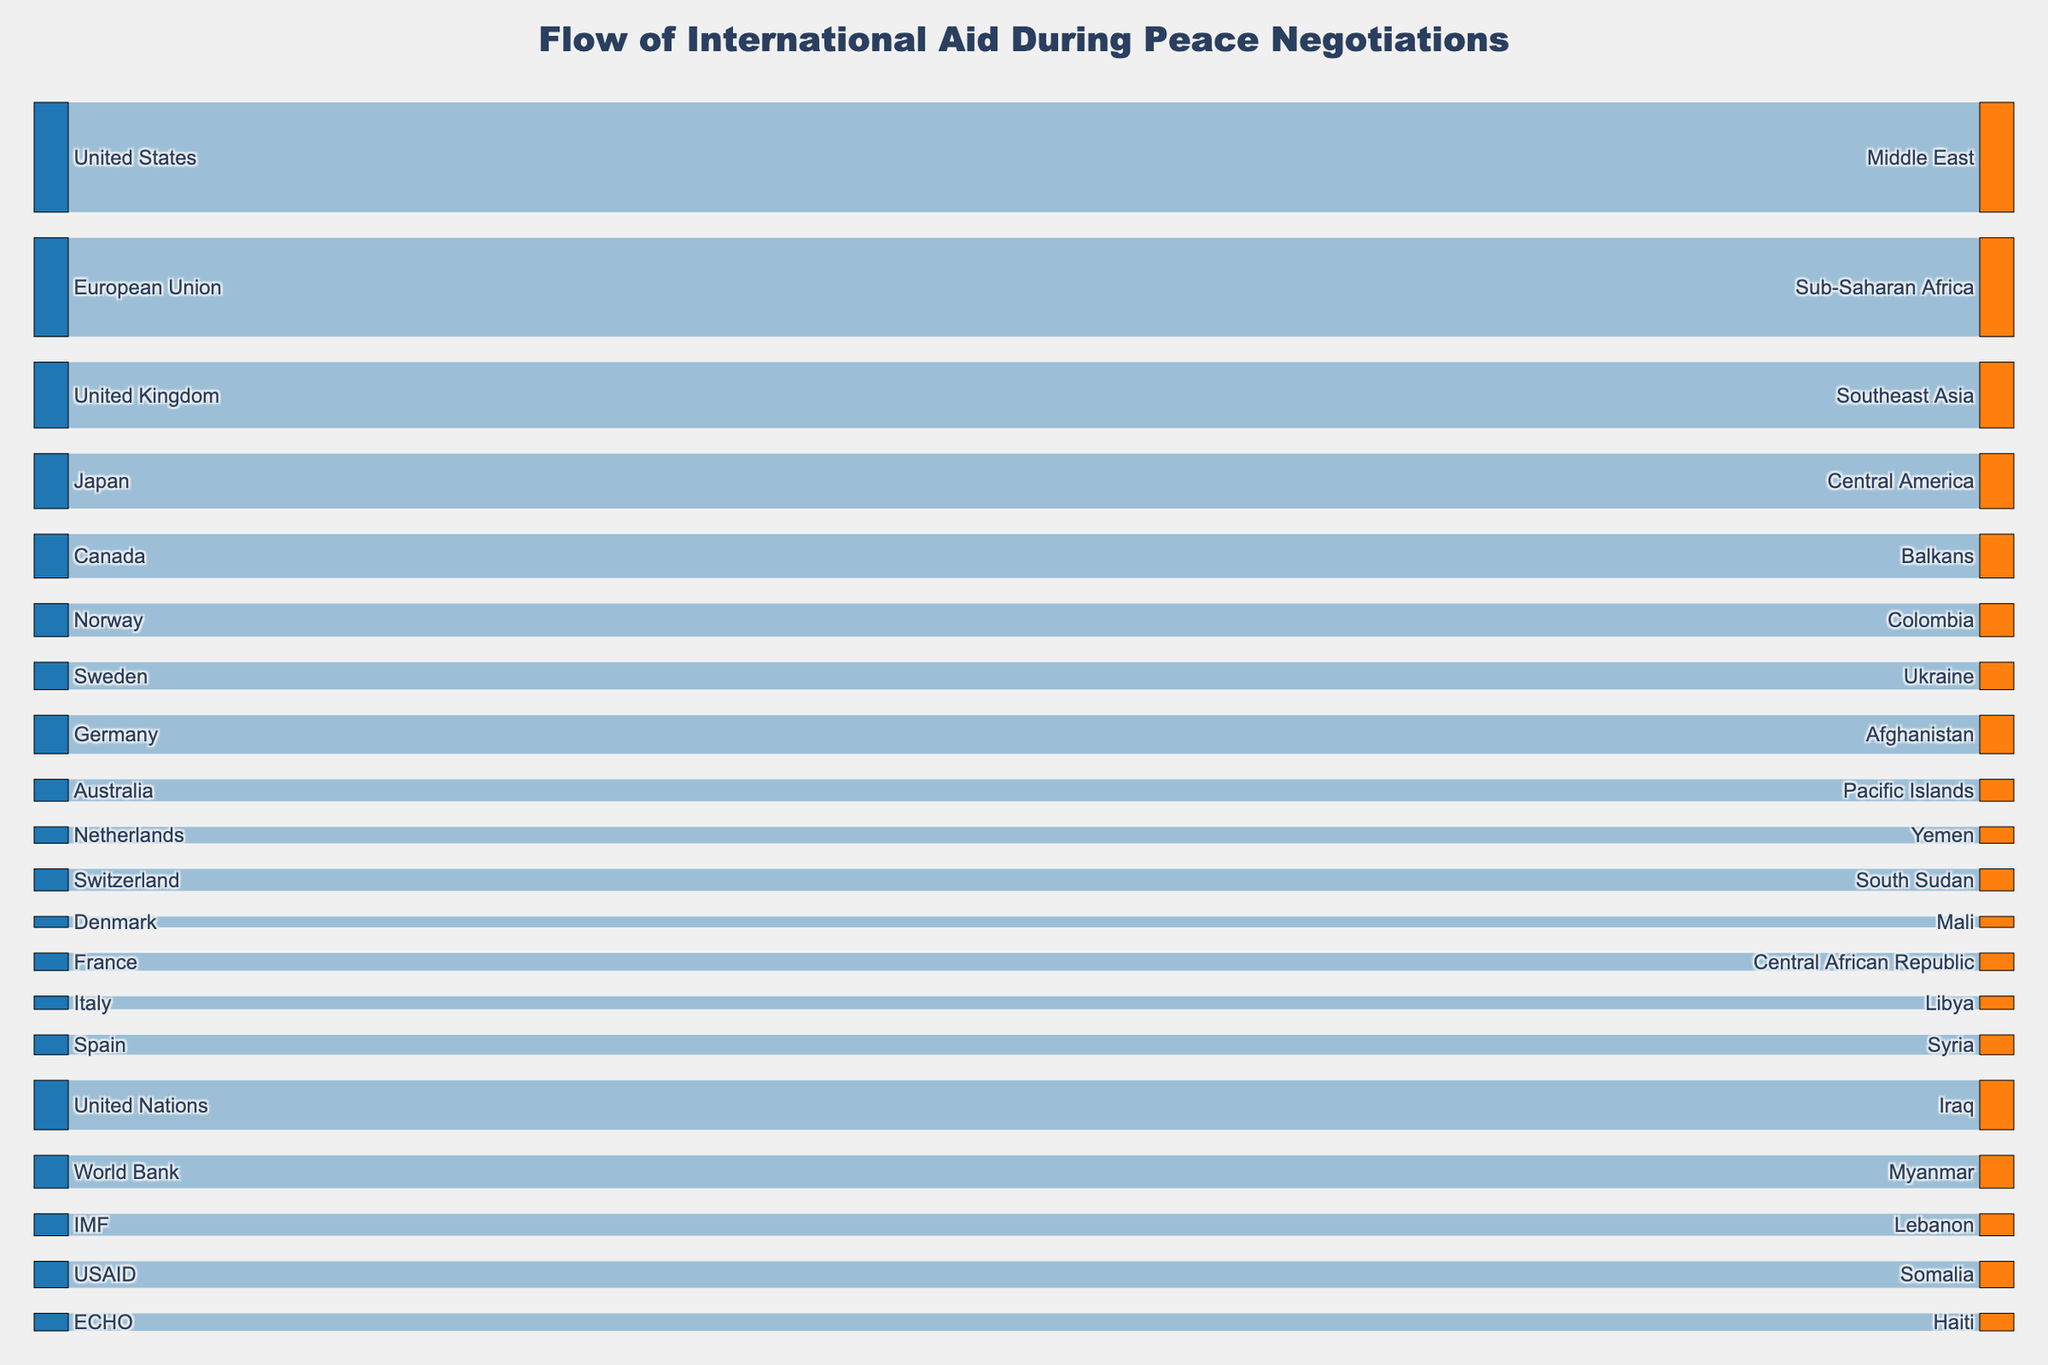what is the title of the figure? The title of the figure is located at the top of the graph. It is usually centered and distinct in styling.
Answer: Flow of International Aid During Peace Negotiations how many donor countries are represented in the figure? Count the number of unique donor countries listed on the left side of the Sankey diagram.
Answer: 20 which two recipient regions are receiving aid from non-country organizations (e.g., United Nations, World Bank, IMF)? Identify the non-country organizations listed on the donor side and trace their aid flows to the recipient regions.
Answer: Iraq, Lebanon what is the total amount of aid flowing to Central America? Find the flow originating from Japan to Central America and note its value. There seems to be only one direct flow.
Answer: 250 which donor country is giving the smallest amount of aid and how much is it? Look for the smallest value in the source section of the diagram and identify the corresponding donor country.
Answer: Denmark, 50 what's the combined amount of aid provided by USAID and ECHO? Locate the aid values from both USAID and ECHO and sum them up. 120 (USAID to Somalia) + 80 (ECHO to Haiti)
Answer: 200 based on the visual, identify which recipient region receives the highest amount of aid from a single donor? Look for the single largest flow among all the connections in the Sankey diagram and trace it to the recipient region.
Answer: Middle East (from the United States) what's the difference in aid amounts between the United States and Germany? Identify the aid amounts from both countries (500 for the United States to Middle East, 175 for Germany to Afghanistan) and calculate the difference.
Answer: 325 how many recipient regions receive aid amounts of at least 150 units? Count the number of flows from donor countries/organizations to recipient regions where the value is 150 or higher.
Answer: 8 which donor-country contributes to two different regions with exactly the same value? Identify donor countries and check if any have the same aid value going to two different recipient regions. Match the value of 100.
Answer: Australia (Pacific Islands) and IMF (Lebanon) 